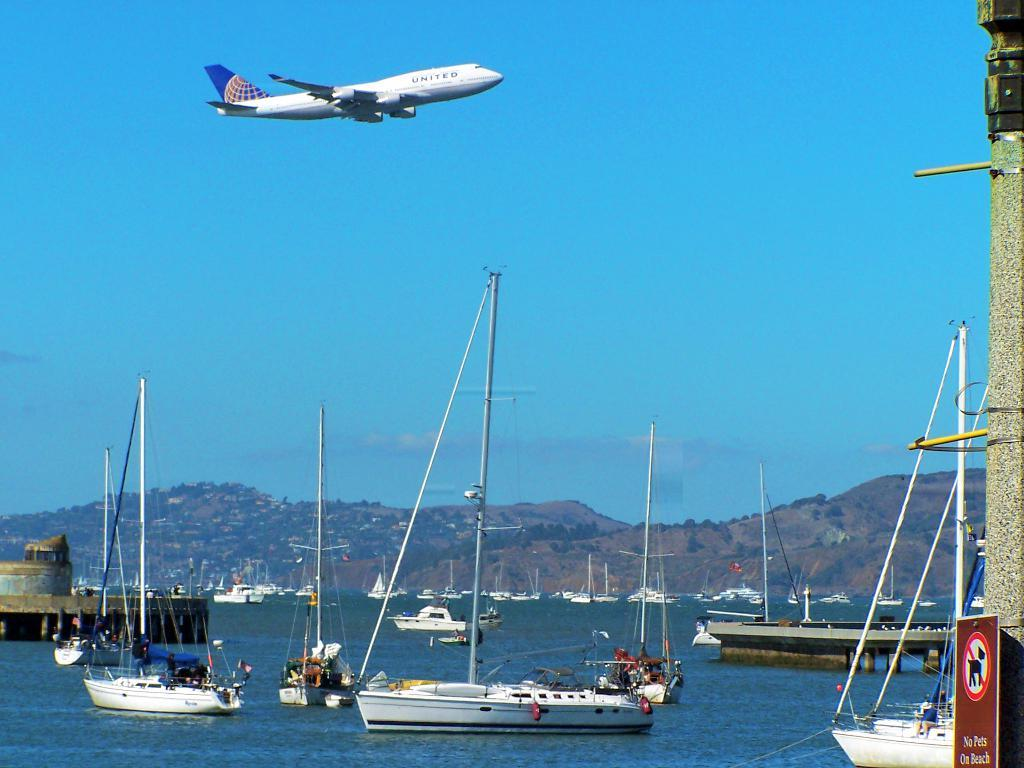<image>
Present a compact description of the photo's key features. A white United Airplane flying over water with boats in it. 